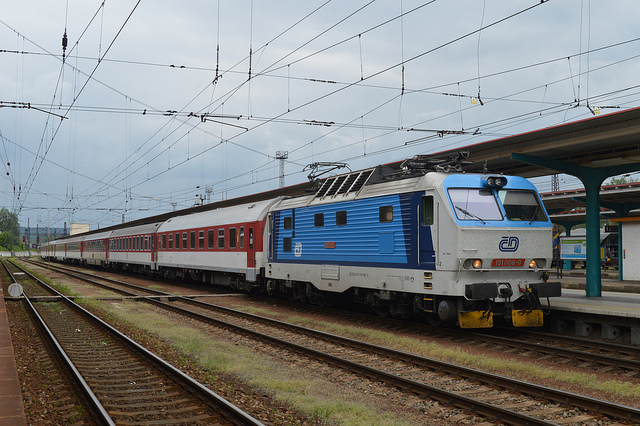<image>What color is the vehicle next to the train? It is unknown what color the vehicle next to the train is. It can be red, gray, white or blue. Alternatively there may not be another vehicle in the image. What color is the vehicle next to the train? I don't know what color is the vehicle next to the train. It can be red, gray, red and white, unknown, white or blue. 